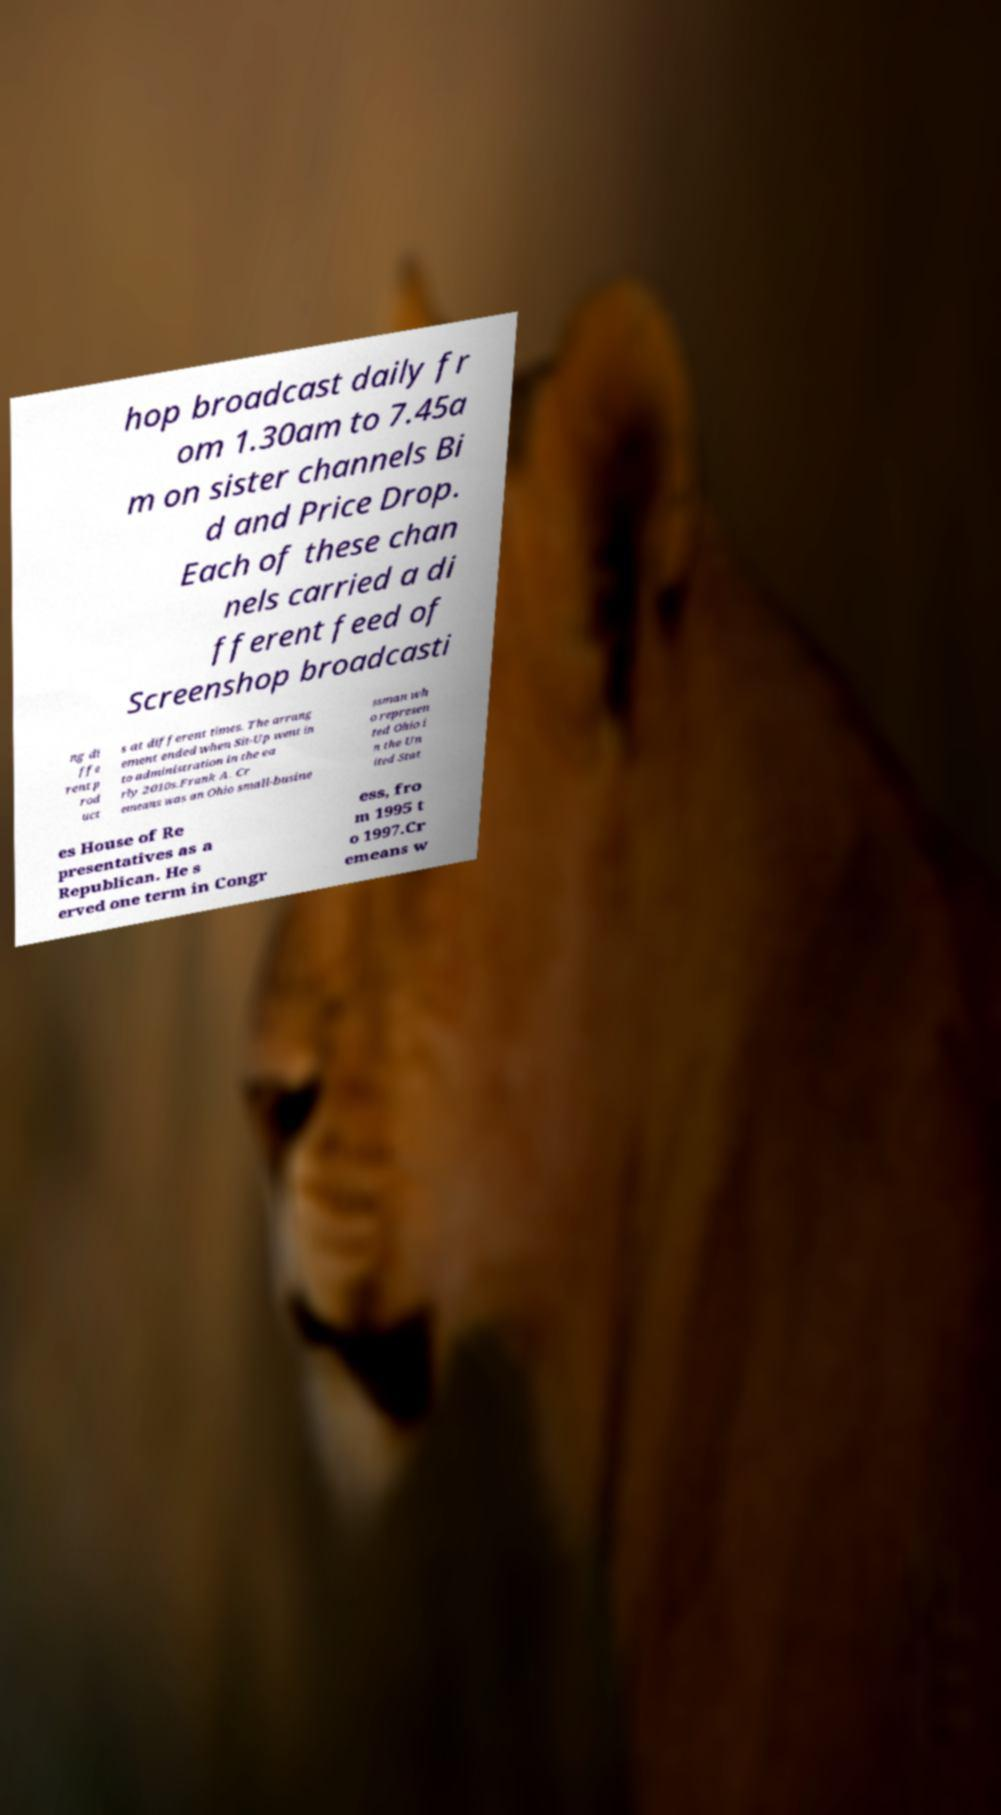I need the written content from this picture converted into text. Can you do that? hop broadcast daily fr om 1.30am to 7.45a m on sister channels Bi d and Price Drop. Each of these chan nels carried a di fferent feed of Screenshop broadcasti ng di ffe rent p rod uct s at different times. The arrang ement ended when Sit-Up went in to administration in the ea rly 2010s.Frank A. Cr emeans was an Ohio small-busine ssman wh o represen ted Ohio i n the Un ited Stat es House of Re presentatives as a Republican. He s erved one term in Congr ess, fro m 1995 t o 1997.Cr emeans w 